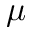Convert formula to latex. <formula><loc_0><loc_0><loc_500><loc_500>\mu</formula> 